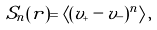<formula> <loc_0><loc_0><loc_500><loc_500>S _ { n } ( r ) = \left \langle ( v _ { + } - v _ { - } ) ^ { n } \right \rangle ,</formula> 